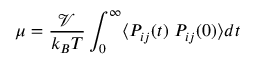Convert formula to latex. <formula><loc_0><loc_0><loc_500><loc_500>\mu = \frac { \mathcal { V } } { k _ { B } T } \int _ { 0 } ^ { \infty } \langle P _ { i j } ( t ) P _ { i j } ( 0 ) \rangle d t</formula> 